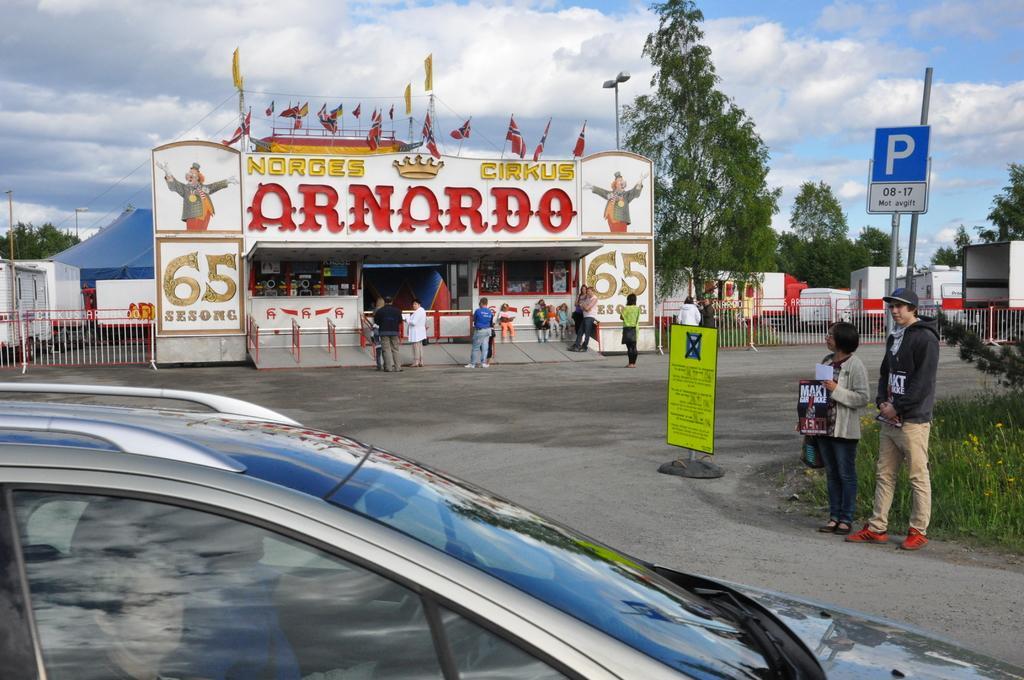How would you summarize this image in a sentence or two? In the picture we can see a car with windshield and a glass window and some people are sitting in the car and besides, we can see some people standing near the path with some grass plants in the path and a pole with a board in the background, we can see a circus exit with some people standing near it and on the exit of the circus we can see some flags are placed and besides the exit we can see a railing and in the background we can see some trees, sky and clouds. 